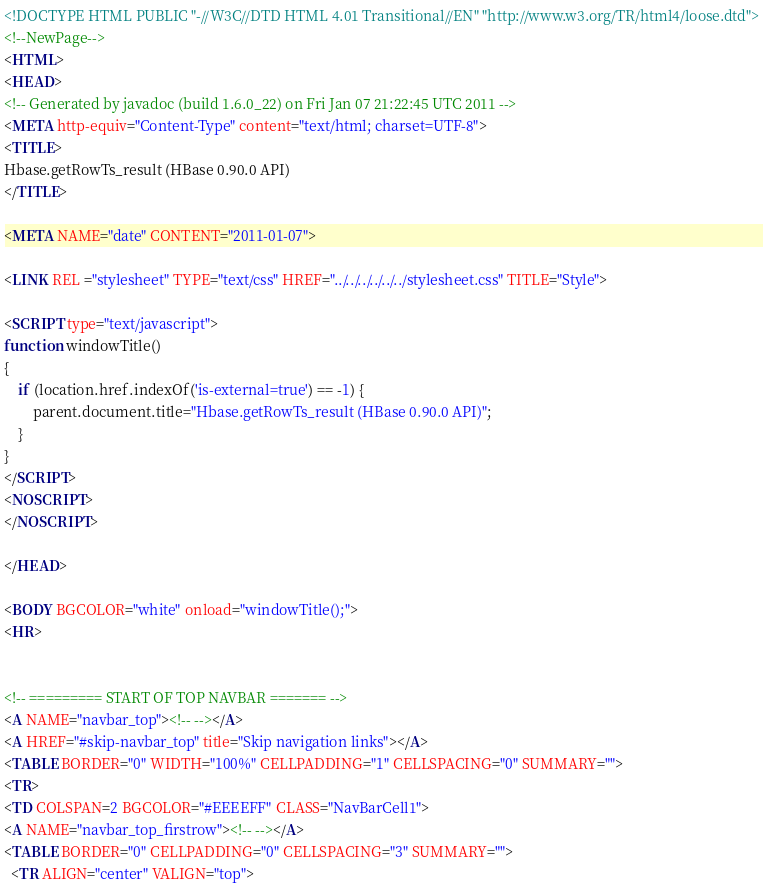<code> <loc_0><loc_0><loc_500><loc_500><_HTML_><!DOCTYPE HTML PUBLIC "-//W3C//DTD HTML 4.01 Transitional//EN" "http://www.w3.org/TR/html4/loose.dtd">
<!--NewPage-->
<HTML>
<HEAD>
<!-- Generated by javadoc (build 1.6.0_22) on Fri Jan 07 21:22:45 UTC 2011 -->
<META http-equiv="Content-Type" content="text/html; charset=UTF-8">
<TITLE>
Hbase.getRowTs_result (HBase 0.90.0 API)
</TITLE>

<META NAME="date" CONTENT="2011-01-07">

<LINK REL ="stylesheet" TYPE="text/css" HREF="../../../../../../stylesheet.css" TITLE="Style">

<SCRIPT type="text/javascript">
function windowTitle()
{
    if (location.href.indexOf('is-external=true') == -1) {
        parent.document.title="Hbase.getRowTs_result (HBase 0.90.0 API)";
    }
}
</SCRIPT>
<NOSCRIPT>
</NOSCRIPT>

</HEAD>

<BODY BGCOLOR="white" onload="windowTitle();">
<HR>


<!-- ========= START OF TOP NAVBAR ======= -->
<A NAME="navbar_top"><!-- --></A>
<A HREF="#skip-navbar_top" title="Skip navigation links"></A>
<TABLE BORDER="0" WIDTH="100%" CELLPADDING="1" CELLSPACING="0" SUMMARY="">
<TR>
<TD COLSPAN=2 BGCOLOR="#EEEEFF" CLASS="NavBarCell1">
<A NAME="navbar_top_firstrow"><!-- --></A>
<TABLE BORDER="0" CELLPADDING="0" CELLSPACING="3" SUMMARY="">
  <TR ALIGN="center" VALIGN="top"></code> 